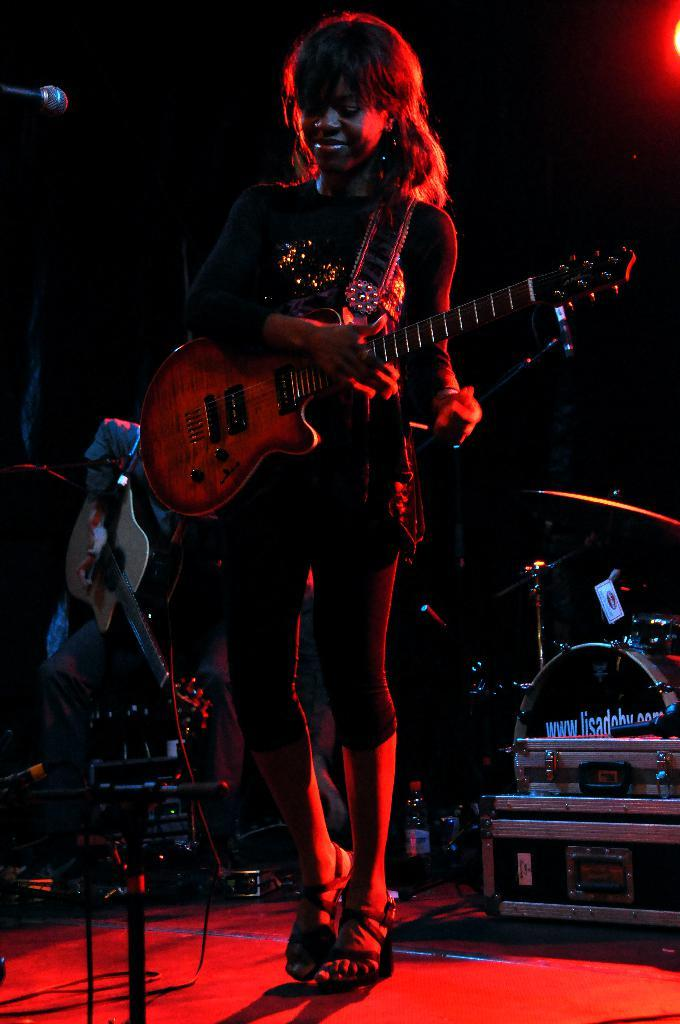What is the lady in the image wearing? The lady is wearing a black dress. What is the lady holding in the image? The lady is holding a guitar. What is the lady doing with the guitar? The lady is playing the guitar. Where is the lady positioned in relation to the microphone? The lady is in front of a microphone. What is the man in the image doing? The man is playing a musical instrument. What type of animal is the lady using to play the guitar in the image? There is no animal present in the image, and the lady is playing the guitar without the assistance of any animal. 